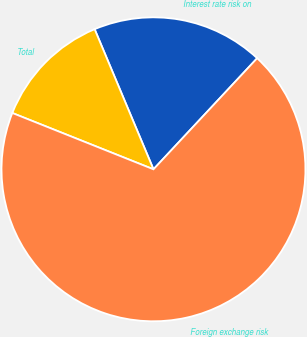Convert chart. <chart><loc_0><loc_0><loc_500><loc_500><pie_chart><fcel>Interest rate risk on<fcel>Total<fcel>Foreign exchange risk<nl><fcel>18.28%<fcel>12.63%<fcel>69.1%<nl></chart> 